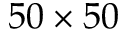Convert formula to latex. <formula><loc_0><loc_0><loc_500><loc_500>5 0 \times 5 0</formula> 